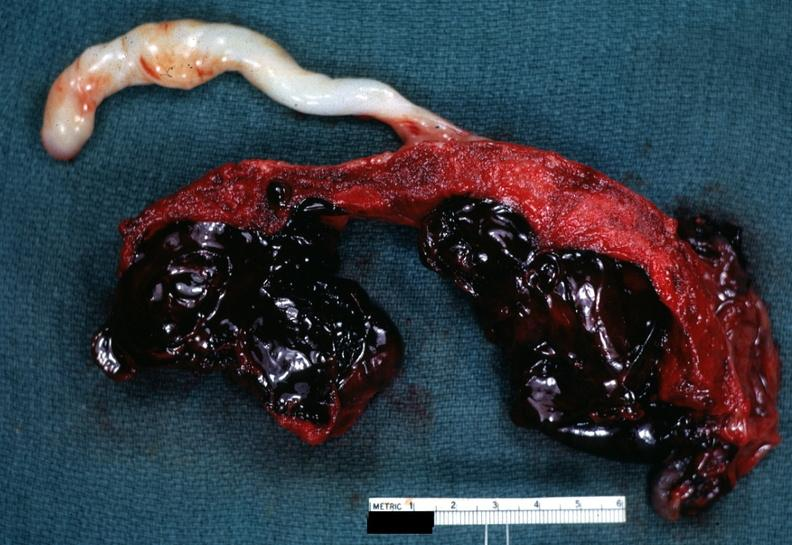s gout present?
Answer the question using a single word or phrase. No 